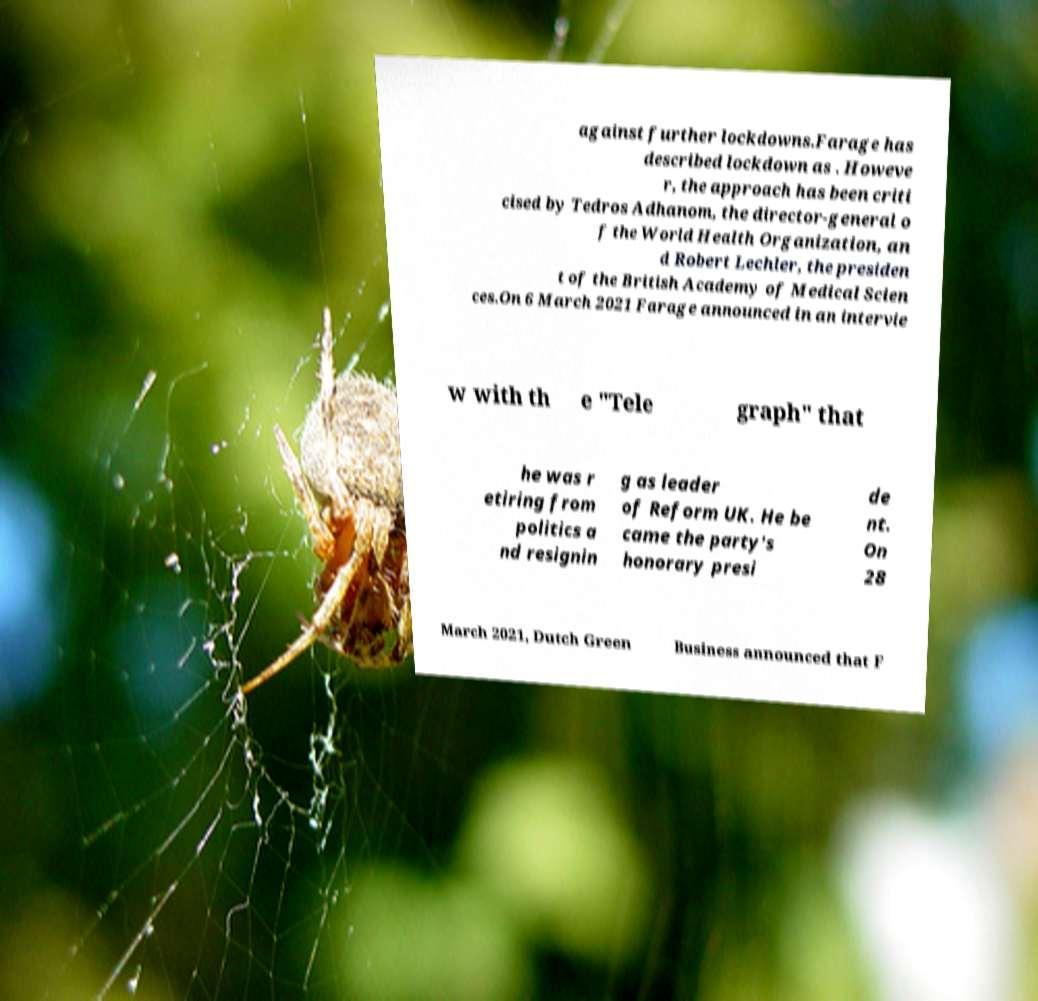I need the written content from this picture converted into text. Can you do that? against further lockdowns.Farage has described lockdown as . Howeve r, the approach has been criti cised by Tedros Adhanom, the director-general o f the World Health Organization, an d Robert Lechler, the presiden t of the British Academy of Medical Scien ces.On 6 March 2021 Farage announced in an intervie w with th e "Tele graph" that he was r etiring from politics a nd resignin g as leader of Reform UK. He be came the party's honorary presi de nt. On 28 March 2021, Dutch Green Business announced that F 